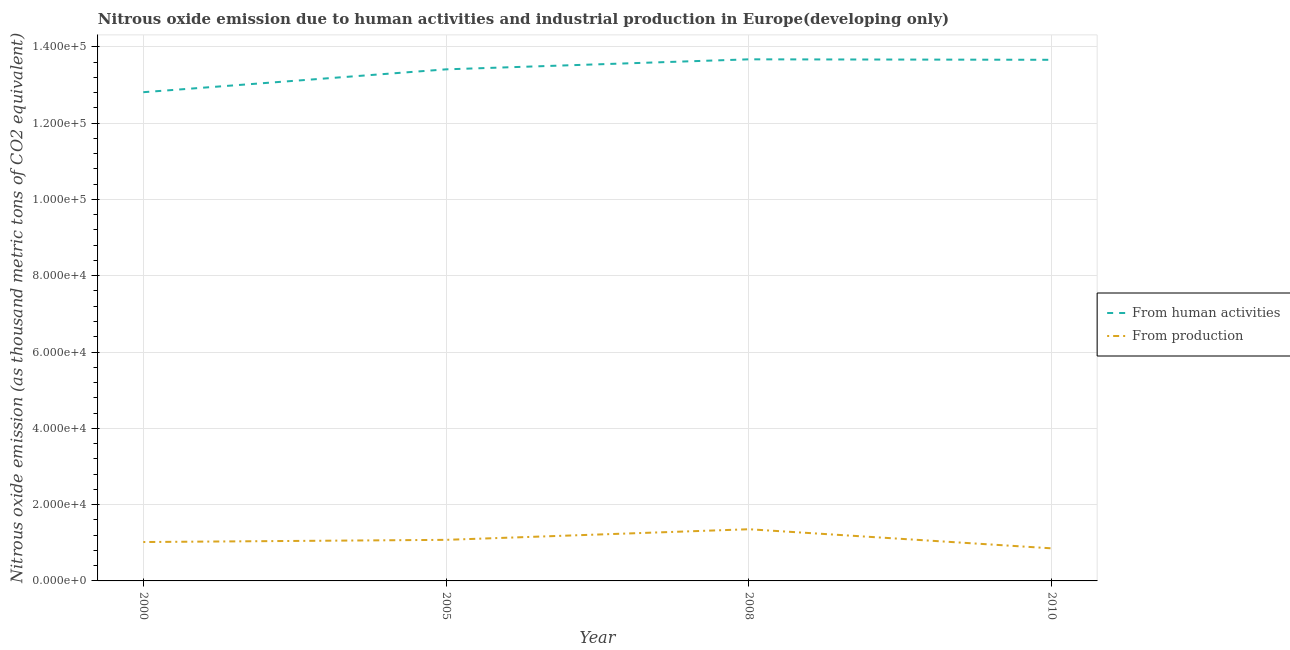How many different coloured lines are there?
Offer a terse response. 2. What is the amount of emissions generated from industries in 2008?
Keep it short and to the point. 1.35e+04. Across all years, what is the maximum amount of emissions generated from industries?
Keep it short and to the point. 1.35e+04. Across all years, what is the minimum amount of emissions from human activities?
Give a very brief answer. 1.28e+05. In which year was the amount of emissions generated from industries minimum?
Give a very brief answer. 2010. What is the total amount of emissions from human activities in the graph?
Keep it short and to the point. 5.36e+05. What is the difference between the amount of emissions generated from industries in 2005 and that in 2010?
Ensure brevity in your answer.  2228. What is the difference between the amount of emissions from human activities in 2010 and the amount of emissions generated from industries in 2000?
Your response must be concise. 1.26e+05. What is the average amount of emissions from human activities per year?
Your answer should be very brief. 1.34e+05. In the year 2005, what is the difference between the amount of emissions generated from industries and amount of emissions from human activities?
Keep it short and to the point. -1.23e+05. What is the ratio of the amount of emissions from human activities in 2000 to that in 2005?
Make the answer very short. 0.96. Is the amount of emissions from human activities in 2008 less than that in 2010?
Offer a terse response. No. What is the difference between the highest and the second highest amount of emissions from human activities?
Provide a succinct answer. 123. What is the difference between the highest and the lowest amount of emissions generated from industries?
Ensure brevity in your answer.  5008.6. Is the amount of emissions from human activities strictly greater than the amount of emissions generated from industries over the years?
Give a very brief answer. Yes. Is the amount of emissions generated from industries strictly less than the amount of emissions from human activities over the years?
Offer a terse response. Yes. How many years are there in the graph?
Ensure brevity in your answer.  4. What is the difference between two consecutive major ticks on the Y-axis?
Your response must be concise. 2.00e+04. Does the graph contain any zero values?
Offer a very short reply. No. Where does the legend appear in the graph?
Ensure brevity in your answer.  Center right. How many legend labels are there?
Provide a short and direct response. 2. What is the title of the graph?
Your answer should be very brief. Nitrous oxide emission due to human activities and industrial production in Europe(developing only). Does "Lowest 10% of population" appear as one of the legend labels in the graph?
Your answer should be compact. No. What is the label or title of the X-axis?
Your response must be concise. Year. What is the label or title of the Y-axis?
Make the answer very short. Nitrous oxide emission (as thousand metric tons of CO2 equivalent). What is the Nitrous oxide emission (as thousand metric tons of CO2 equivalent) in From human activities in 2000?
Provide a succinct answer. 1.28e+05. What is the Nitrous oxide emission (as thousand metric tons of CO2 equivalent) of From production in 2000?
Your answer should be very brief. 1.02e+04. What is the Nitrous oxide emission (as thousand metric tons of CO2 equivalent) in From human activities in 2005?
Offer a very short reply. 1.34e+05. What is the Nitrous oxide emission (as thousand metric tons of CO2 equivalent) in From production in 2005?
Give a very brief answer. 1.08e+04. What is the Nitrous oxide emission (as thousand metric tons of CO2 equivalent) in From human activities in 2008?
Ensure brevity in your answer.  1.37e+05. What is the Nitrous oxide emission (as thousand metric tons of CO2 equivalent) in From production in 2008?
Your response must be concise. 1.35e+04. What is the Nitrous oxide emission (as thousand metric tons of CO2 equivalent) of From human activities in 2010?
Ensure brevity in your answer.  1.37e+05. What is the Nitrous oxide emission (as thousand metric tons of CO2 equivalent) in From production in 2010?
Ensure brevity in your answer.  8539.4. Across all years, what is the maximum Nitrous oxide emission (as thousand metric tons of CO2 equivalent) of From human activities?
Make the answer very short. 1.37e+05. Across all years, what is the maximum Nitrous oxide emission (as thousand metric tons of CO2 equivalent) of From production?
Provide a succinct answer. 1.35e+04. Across all years, what is the minimum Nitrous oxide emission (as thousand metric tons of CO2 equivalent) of From human activities?
Your answer should be compact. 1.28e+05. Across all years, what is the minimum Nitrous oxide emission (as thousand metric tons of CO2 equivalent) in From production?
Offer a very short reply. 8539.4. What is the total Nitrous oxide emission (as thousand metric tons of CO2 equivalent) of From human activities in the graph?
Your response must be concise. 5.36e+05. What is the total Nitrous oxide emission (as thousand metric tons of CO2 equivalent) of From production in the graph?
Give a very brief answer. 4.30e+04. What is the difference between the Nitrous oxide emission (as thousand metric tons of CO2 equivalent) of From human activities in 2000 and that in 2005?
Provide a succinct answer. -5992.3. What is the difference between the Nitrous oxide emission (as thousand metric tons of CO2 equivalent) of From production in 2000 and that in 2005?
Provide a succinct answer. -574. What is the difference between the Nitrous oxide emission (as thousand metric tons of CO2 equivalent) of From human activities in 2000 and that in 2008?
Give a very brief answer. -8618.7. What is the difference between the Nitrous oxide emission (as thousand metric tons of CO2 equivalent) in From production in 2000 and that in 2008?
Keep it short and to the point. -3354.6. What is the difference between the Nitrous oxide emission (as thousand metric tons of CO2 equivalent) of From human activities in 2000 and that in 2010?
Make the answer very short. -8495.7. What is the difference between the Nitrous oxide emission (as thousand metric tons of CO2 equivalent) of From production in 2000 and that in 2010?
Your response must be concise. 1654. What is the difference between the Nitrous oxide emission (as thousand metric tons of CO2 equivalent) in From human activities in 2005 and that in 2008?
Your answer should be very brief. -2626.4. What is the difference between the Nitrous oxide emission (as thousand metric tons of CO2 equivalent) of From production in 2005 and that in 2008?
Your response must be concise. -2780.6. What is the difference between the Nitrous oxide emission (as thousand metric tons of CO2 equivalent) in From human activities in 2005 and that in 2010?
Ensure brevity in your answer.  -2503.4. What is the difference between the Nitrous oxide emission (as thousand metric tons of CO2 equivalent) of From production in 2005 and that in 2010?
Offer a terse response. 2228. What is the difference between the Nitrous oxide emission (as thousand metric tons of CO2 equivalent) of From human activities in 2008 and that in 2010?
Provide a succinct answer. 123. What is the difference between the Nitrous oxide emission (as thousand metric tons of CO2 equivalent) of From production in 2008 and that in 2010?
Offer a terse response. 5008.6. What is the difference between the Nitrous oxide emission (as thousand metric tons of CO2 equivalent) of From human activities in 2000 and the Nitrous oxide emission (as thousand metric tons of CO2 equivalent) of From production in 2005?
Offer a terse response. 1.17e+05. What is the difference between the Nitrous oxide emission (as thousand metric tons of CO2 equivalent) in From human activities in 2000 and the Nitrous oxide emission (as thousand metric tons of CO2 equivalent) in From production in 2008?
Your answer should be very brief. 1.15e+05. What is the difference between the Nitrous oxide emission (as thousand metric tons of CO2 equivalent) in From human activities in 2000 and the Nitrous oxide emission (as thousand metric tons of CO2 equivalent) in From production in 2010?
Offer a terse response. 1.20e+05. What is the difference between the Nitrous oxide emission (as thousand metric tons of CO2 equivalent) in From human activities in 2005 and the Nitrous oxide emission (as thousand metric tons of CO2 equivalent) in From production in 2008?
Offer a very short reply. 1.21e+05. What is the difference between the Nitrous oxide emission (as thousand metric tons of CO2 equivalent) of From human activities in 2005 and the Nitrous oxide emission (as thousand metric tons of CO2 equivalent) of From production in 2010?
Your answer should be very brief. 1.26e+05. What is the difference between the Nitrous oxide emission (as thousand metric tons of CO2 equivalent) of From human activities in 2008 and the Nitrous oxide emission (as thousand metric tons of CO2 equivalent) of From production in 2010?
Make the answer very short. 1.28e+05. What is the average Nitrous oxide emission (as thousand metric tons of CO2 equivalent) in From human activities per year?
Offer a very short reply. 1.34e+05. What is the average Nitrous oxide emission (as thousand metric tons of CO2 equivalent) of From production per year?
Provide a succinct answer. 1.08e+04. In the year 2000, what is the difference between the Nitrous oxide emission (as thousand metric tons of CO2 equivalent) of From human activities and Nitrous oxide emission (as thousand metric tons of CO2 equivalent) of From production?
Your answer should be compact. 1.18e+05. In the year 2005, what is the difference between the Nitrous oxide emission (as thousand metric tons of CO2 equivalent) in From human activities and Nitrous oxide emission (as thousand metric tons of CO2 equivalent) in From production?
Your response must be concise. 1.23e+05. In the year 2008, what is the difference between the Nitrous oxide emission (as thousand metric tons of CO2 equivalent) of From human activities and Nitrous oxide emission (as thousand metric tons of CO2 equivalent) of From production?
Your answer should be compact. 1.23e+05. In the year 2010, what is the difference between the Nitrous oxide emission (as thousand metric tons of CO2 equivalent) in From human activities and Nitrous oxide emission (as thousand metric tons of CO2 equivalent) in From production?
Make the answer very short. 1.28e+05. What is the ratio of the Nitrous oxide emission (as thousand metric tons of CO2 equivalent) of From human activities in 2000 to that in 2005?
Your answer should be compact. 0.96. What is the ratio of the Nitrous oxide emission (as thousand metric tons of CO2 equivalent) in From production in 2000 to that in 2005?
Your answer should be compact. 0.95. What is the ratio of the Nitrous oxide emission (as thousand metric tons of CO2 equivalent) of From human activities in 2000 to that in 2008?
Provide a succinct answer. 0.94. What is the ratio of the Nitrous oxide emission (as thousand metric tons of CO2 equivalent) in From production in 2000 to that in 2008?
Your answer should be compact. 0.75. What is the ratio of the Nitrous oxide emission (as thousand metric tons of CO2 equivalent) in From human activities in 2000 to that in 2010?
Your response must be concise. 0.94. What is the ratio of the Nitrous oxide emission (as thousand metric tons of CO2 equivalent) in From production in 2000 to that in 2010?
Offer a terse response. 1.19. What is the ratio of the Nitrous oxide emission (as thousand metric tons of CO2 equivalent) in From human activities in 2005 to that in 2008?
Keep it short and to the point. 0.98. What is the ratio of the Nitrous oxide emission (as thousand metric tons of CO2 equivalent) of From production in 2005 to that in 2008?
Keep it short and to the point. 0.79. What is the ratio of the Nitrous oxide emission (as thousand metric tons of CO2 equivalent) of From human activities in 2005 to that in 2010?
Offer a very short reply. 0.98. What is the ratio of the Nitrous oxide emission (as thousand metric tons of CO2 equivalent) of From production in 2005 to that in 2010?
Your response must be concise. 1.26. What is the ratio of the Nitrous oxide emission (as thousand metric tons of CO2 equivalent) of From production in 2008 to that in 2010?
Your answer should be compact. 1.59. What is the difference between the highest and the second highest Nitrous oxide emission (as thousand metric tons of CO2 equivalent) in From human activities?
Offer a terse response. 123. What is the difference between the highest and the second highest Nitrous oxide emission (as thousand metric tons of CO2 equivalent) in From production?
Keep it short and to the point. 2780.6. What is the difference between the highest and the lowest Nitrous oxide emission (as thousand metric tons of CO2 equivalent) of From human activities?
Your response must be concise. 8618.7. What is the difference between the highest and the lowest Nitrous oxide emission (as thousand metric tons of CO2 equivalent) of From production?
Make the answer very short. 5008.6. 